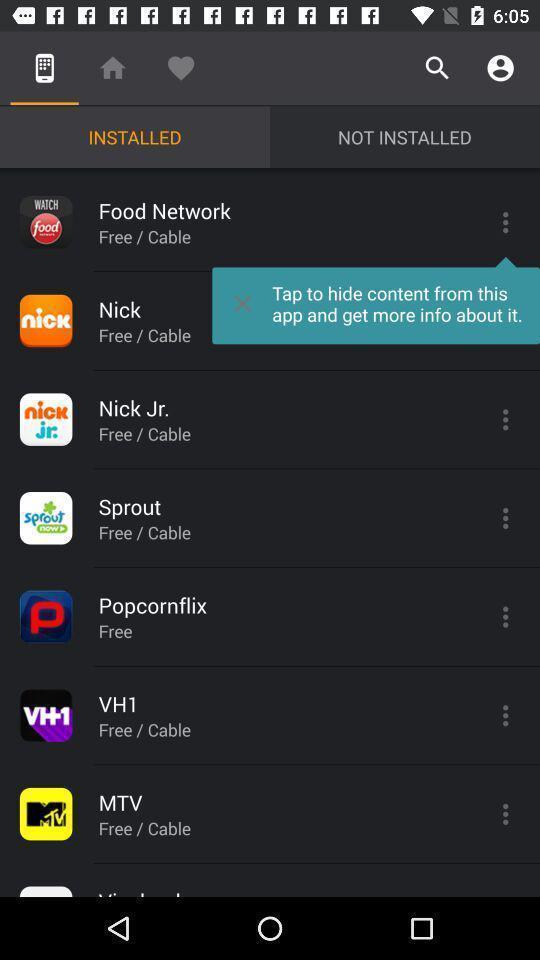What can you discern from this picture? Screen shows an installed content. 